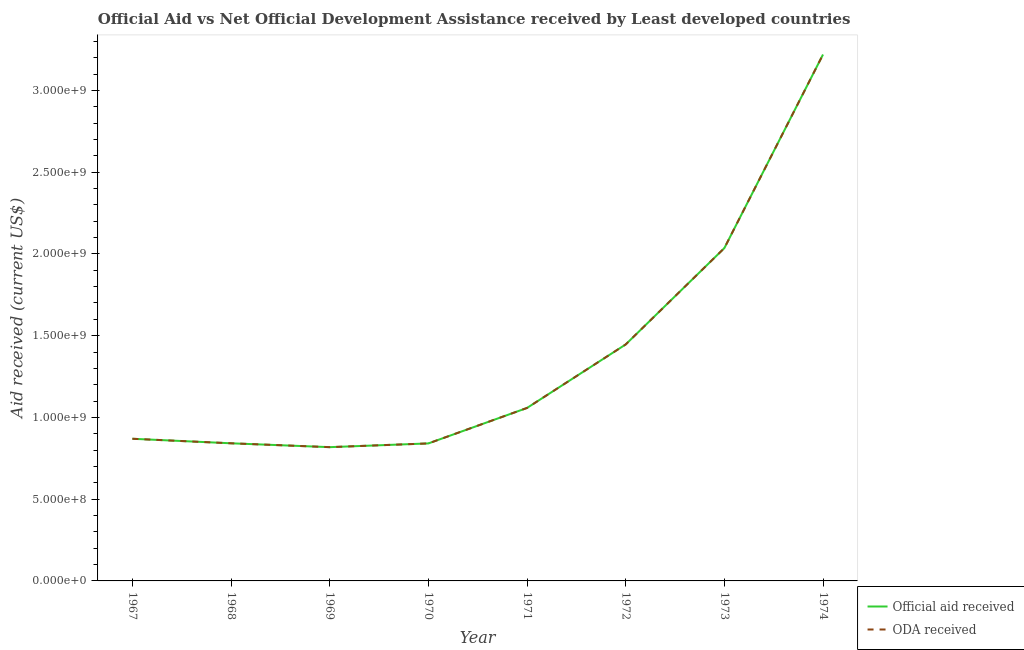What is the official aid received in 1971?
Offer a very short reply. 1.06e+09. Across all years, what is the maximum official aid received?
Give a very brief answer. 3.22e+09. Across all years, what is the minimum official aid received?
Make the answer very short. 8.18e+08. In which year was the oda received maximum?
Your answer should be compact. 1974. In which year was the oda received minimum?
Provide a short and direct response. 1969. What is the total official aid received in the graph?
Your answer should be very brief. 1.11e+1. What is the difference between the official aid received in 1968 and that in 1970?
Provide a short and direct response. 7.80e+05. What is the difference between the oda received in 1969 and the official aid received in 1973?
Ensure brevity in your answer.  -1.22e+09. What is the average oda received per year?
Offer a very short reply. 1.39e+09. In the year 1973, what is the difference between the oda received and official aid received?
Make the answer very short. 0. What is the ratio of the official aid received in 1968 to that in 1970?
Provide a short and direct response. 1. Is the official aid received in 1967 less than that in 1973?
Your answer should be very brief. Yes. Is the difference between the official aid received in 1967 and 1974 greater than the difference between the oda received in 1967 and 1974?
Ensure brevity in your answer.  No. What is the difference between the highest and the second highest official aid received?
Your answer should be very brief. 1.18e+09. What is the difference between the highest and the lowest oda received?
Your answer should be very brief. 2.40e+09. Is the official aid received strictly less than the oda received over the years?
Offer a very short reply. No. How many lines are there?
Ensure brevity in your answer.  2. How many years are there in the graph?
Your response must be concise. 8. Are the values on the major ticks of Y-axis written in scientific E-notation?
Keep it short and to the point. Yes. Where does the legend appear in the graph?
Provide a short and direct response. Bottom right. How many legend labels are there?
Keep it short and to the point. 2. How are the legend labels stacked?
Offer a terse response. Vertical. What is the title of the graph?
Make the answer very short. Official Aid vs Net Official Development Assistance received by Least developed countries . What is the label or title of the Y-axis?
Provide a succinct answer. Aid received (current US$). What is the Aid received (current US$) in Official aid received in 1967?
Keep it short and to the point. 8.69e+08. What is the Aid received (current US$) of ODA received in 1967?
Your answer should be very brief. 8.69e+08. What is the Aid received (current US$) in Official aid received in 1968?
Give a very brief answer. 8.42e+08. What is the Aid received (current US$) in ODA received in 1968?
Keep it short and to the point. 8.42e+08. What is the Aid received (current US$) in Official aid received in 1969?
Your answer should be very brief. 8.18e+08. What is the Aid received (current US$) of ODA received in 1969?
Your response must be concise. 8.18e+08. What is the Aid received (current US$) of Official aid received in 1970?
Offer a very short reply. 8.41e+08. What is the Aid received (current US$) of ODA received in 1970?
Provide a short and direct response. 8.41e+08. What is the Aid received (current US$) in Official aid received in 1971?
Ensure brevity in your answer.  1.06e+09. What is the Aid received (current US$) of ODA received in 1971?
Keep it short and to the point. 1.06e+09. What is the Aid received (current US$) of Official aid received in 1972?
Your answer should be very brief. 1.45e+09. What is the Aid received (current US$) of ODA received in 1972?
Give a very brief answer. 1.45e+09. What is the Aid received (current US$) in Official aid received in 1973?
Provide a short and direct response. 2.04e+09. What is the Aid received (current US$) of ODA received in 1973?
Offer a terse response. 2.04e+09. What is the Aid received (current US$) in Official aid received in 1974?
Give a very brief answer. 3.22e+09. What is the Aid received (current US$) in ODA received in 1974?
Provide a short and direct response. 3.22e+09. Across all years, what is the maximum Aid received (current US$) in Official aid received?
Offer a very short reply. 3.22e+09. Across all years, what is the maximum Aid received (current US$) in ODA received?
Give a very brief answer. 3.22e+09. Across all years, what is the minimum Aid received (current US$) in Official aid received?
Your response must be concise. 8.18e+08. Across all years, what is the minimum Aid received (current US$) in ODA received?
Your answer should be very brief. 8.18e+08. What is the total Aid received (current US$) of Official aid received in the graph?
Offer a terse response. 1.11e+1. What is the total Aid received (current US$) in ODA received in the graph?
Keep it short and to the point. 1.11e+1. What is the difference between the Aid received (current US$) of Official aid received in 1967 and that in 1968?
Keep it short and to the point. 2.77e+07. What is the difference between the Aid received (current US$) of ODA received in 1967 and that in 1968?
Provide a short and direct response. 2.77e+07. What is the difference between the Aid received (current US$) in Official aid received in 1967 and that in 1969?
Ensure brevity in your answer.  5.13e+07. What is the difference between the Aid received (current US$) in ODA received in 1967 and that in 1969?
Make the answer very short. 5.13e+07. What is the difference between the Aid received (current US$) of Official aid received in 1967 and that in 1970?
Your response must be concise. 2.85e+07. What is the difference between the Aid received (current US$) of ODA received in 1967 and that in 1970?
Your answer should be very brief. 2.85e+07. What is the difference between the Aid received (current US$) in Official aid received in 1967 and that in 1971?
Offer a very short reply. -1.88e+08. What is the difference between the Aid received (current US$) of ODA received in 1967 and that in 1971?
Give a very brief answer. -1.88e+08. What is the difference between the Aid received (current US$) of Official aid received in 1967 and that in 1972?
Your answer should be very brief. -5.77e+08. What is the difference between the Aid received (current US$) of ODA received in 1967 and that in 1972?
Your response must be concise. -5.77e+08. What is the difference between the Aid received (current US$) of Official aid received in 1967 and that in 1973?
Your answer should be compact. -1.17e+09. What is the difference between the Aid received (current US$) of ODA received in 1967 and that in 1973?
Provide a short and direct response. -1.17e+09. What is the difference between the Aid received (current US$) in Official aid received in 1967 and that in 1974?
Your answer should be compact. -2.35e+09. What is the difference between the Aid received (current US$) in ODA received in 1967 and that in 1974?
Provide a succinct answer. -2.35e+09. What is the difference between the Aid received (current US$) of Official aid received in 1968 and that in 1969?
Provide a short and direct response. 2.36e+07. What is the difference between the Aid received (current US$) of ODA received in 1968 and that in 1969?
Provide a short and direct response. 2.36e+07. What is the difference between the Aid received (current US$) in Official aid received in 1968 and that in 1970?
Your answer should be compact. 7.80e+05. What is the difference between the Aid received (current US$) in ODA received in 1968 and that in 1970?
Provide a short and direct response. 7.80e+05. What is the difference between the Aid received (current US$) of Official aid received in 1968 and that in 1971?
Your answer should be compact. -2.16e+08. What is the difference between the Aid received (current US$) in ODA received in 1968 and that in 1971?
Make the answer very short. -2.16e+08. What is the difference between the Aid received (current US$) in Official aid received in 1968 and that in 1972?
Provide a succinct answer. -6.05e+08. What is the difference between the Aid received (current US$) in ODA received in 1968 and that in 1972?
Provide a short and direct response. -6.05e+08. What is the difference between the Aid received (current US$) of Official aid received in 1968 and that in 1973?
Your response must be concise. -1.19e+09. What is the difference between the Aid received (current US$) of ODA received in 1968 and that in 1973?
Your response must be concise. -1.19e+09. What is the difference between the Aid received (current US$) in Official aid received in 1968 and that in 1974?
Your response must be concise. -2.38e+09. What is the difference between the Aid received (current US$) of ODA received in 1968 and that in 1974?
Your response must be concise. -2.38e+09. What is the difference between the Aid received (current US$) of Official aid received in 1969 and that in 1970?
Provide a succinct answer. -2.28e+07. What is the difference between the Aid received (current US$) in ODA received in 1969 and that in 1970?
Your answer should be very brief. -2.28e+07. What is the difference between the Aid received (current US$) in Official aid received in 1969 and that in 1971?
Provide a succinct answer. -2.40e+08. What is the difference between the Aid received (current US$) of ODA received in 1969 and that in 1971?
Your answer should be compact. -2.40e+08. What is the difference between the Aid received (current US$) of Official aid received in 1969 and that in 1972?
Offer a very short reply. -6.28e+08. What is the difference between the Aid received (current US$) in ODA received in 1969 and that in 1972?
Your response must be concise. -6.28e+08. What is the difference between the Aid received (current US$) in Official aid received in 1969 and that in 1973?
Offer a terse response. -1.22e+09. What is the difference between the Aid received (current US$) of ODA received in 1969 and that in 1973?
Ensure brevity in your answer.  -1.22e+09. What is the difference between the Aid received (current US$) of Official aid received in 1969 and that in 1974?
Give a very brief answer. -2.40e+09. What is the difference between the Aid received (current US$) in ODA received in 1969 and that in 1974?
Keep it short and to the point. -2.40e+09. What is the difference between the Aid received (current US$) in Official aid received in 1970 and that in 1971?
Offer a terse response. -2.17e+08. What is the difference between the Aid received (current US$) in ODA received in 1970 and that in 1971?
Give a very brief answer. -2.17e+08. What is the difference between the Aid received (current US$) in Official aid received in 1970 and that in 1972?
Your answer should be compact. -6.05e+08. What is the difference between the Aid received (current US$) in ODA received in 1970 and that in 1972?
Your response must be concise. -6.05e+08. What is the difference between the Aid received (current US$) in Official aid received in 1970 and that in 1973?
Keep it short and to the point. -1.19e+09. What is the difference between the Aid received (current US$) of ODA received in 1970 and that in 1973?
Provide a short and direct response. -1.19e+09. What is the difference between the Aid received (current US$) of Official aid received in 1970 and that in 1974?
Make the answer very short. -2.38e+09. What is the difference between the Aid received (current US$) of ODA received in 1970 and that in 1974?
Your answer should be very brief. -2.38e+09. What is the difference between the Aid received (current US$) in Official aid received in 1971 and that in 1972?
Your answer should be compact. -3.88e+08. What is the difference between the Aid received (current US$) of ODA received in 1971 and that in 1972?
Make the answer very short. -3.88e+08. What is the difference between the Aid received (current US$) in Official aid received in 1971 and that in 1973?
Offer a terse response. -9.78e+08. What is the difference between the Aid received (current US$) of ODA received in 1971 and that in 1973?
Offer a terse response. -9.78e+08. What is the difference between the Aid received (current US$) in Official aid received in 1971 and that in 1974?
Offer a very short reply. -2.16e+09. What is the difference between the Aid received (current US$) of ODA received in 1971 and that in 1974?
Your answer should be compact. -2.16e+09. What is the difference between the Aid received (current US$) in Official aid received in 1972 and that in 1973?
Ensure brevity in your answer.  -5.89e+08. What is the difference between the Aid received (current US$) of ODA received in 1972 and that in 1973?
Your answer should be very brief. -5.89e+08. What is the difference between the Aid received (current US$) in Official aid received in 1972 and that in 1974?
Provide a succinct answer. -1.77e+09. What is the difference between the Aid received (current US$) of ODA received in 1972 and that in 1974?
Your response must be concise. -1.77e+09. What is the difference between the Aid received (current US$) of Official aid received in 1973 and that in 1974?
Offer a terse response. -1.18e+09. What is the difference between the Aid received (current US$) of ODA received in 1973 and that in 1974?
Give a very brief answer. -1.18e+09. What is the difference between the Aid received (current US$) in Official aid received in 1967 and the Aid received (current US$) in ODA received in 1968?
Your response must be concise. 2.77e+07. What is the difference between the Aid received (current US$) in Official aid received in 1967 and the Aid received (current US$) in ODA received in 1969?
Ensure brevity in your answer.  5.13e+07. What is the difference between the Aid received (current US$) in Official aid received in 1967 and the Aid received (current US$) in ODA received in 1970?
Provide a succinct answer. 2.85e+07. What is the difference between the Aid received (current US$) of Official aid received in 1967 and the Aid received (current US$) of ODA received in 1971?
Keep it short and to the point. -1.88e+08. What is the difference between the Aid received (current US$) of Official aid received in 1967 and the Aid received (current US$) of ODA received in 1972?
Provide a short and direct response. -5.77e+08. What is the difference between the Aid received (current US$) in Official aid received in 1967 and the Aid received (current US$) in ODA received in 1973?
Your answer should be very brief. -1.17e+09. What is the difference between the Aid received (current US$) of Official aid received in 1967 and the Aid received (current US$) of ODA received in 1974?
Your response must be concise. -2.35e+09. What is the difference between the Aid received (current US$) in Official aid received in 1968 and the Aid received (current US$) in ODA received in 1969?
Your response must be concise. 2.36e+07. What is the difference between the Aid received (current US$) in Official aid received in 1968 and the Aid received (current US$) in ODA received in 1970?
Provide a succinct answer. 7.80e+05. What is the difference between the Aid received (current US$) in Official aid received in 1968 and the Aid received (current US$) in ODA received in 1971?
Give a very brief answer. -2.16e+08. What is the difference between the Aid received (current US$) in Official aid received in 1968 and the Aid received (current US$) in ODA received in 1972?
Your answer should be very brief. -6.05e+08. What is the difference between the Aid received (current US$) of Official aid received in 1968 and the Aid received (current US$) of ODA received in 1973?
Give a very brief answer. -1.19e+09. What is the difference between the Aid received (current US$) in Official aid received in 1968 and the Aid received (current US$) in ODA received in 1974?
Offer a terse response. -2.38e+09. What is the difference between the Aid received (current US$) of Official aid received in 1969 and the Aid received (current US$) of ODA received in 1970?
Your response must be concise. -2.28e+07. What is the difference between the Aid received (current US$) of Official aid received in 1969 and the Aid received (current US$) of ODA received in 1971?
Keep it short and to the point. -2.40e+08. What is the difference between the Aid received (current US$) in Official aid received in 1969 and the Aid received (current US$) in ODA received in 1972?
Keep it short and to the point. -6.28e+08. What is the difference between the Aid received (current US$) of Official aid received in 1969 and the Aid received (current US$) of ODA received in 1973?
Your answer should be very brief. -1.22e+09. What is the difference between the Aid received (current US$) in Official aid received in 1969 and the Aid received (current US$) in ODA received in 1974?
Provide a succinct answer. -2.40e+09. What is the difference between the Aid received (current US$) of Official aid received in 1970 and the Aid received (current US$) of ODA received in 1971?
Your answer should be very brief. -2.17e+08. What is the difference between the Aid received (current US$) in Official aid received in 1970 and the Aid received (current US$) in ODA received in 1972?
Your answer should be very brief. -6.05e+08. What is the difference between the Aid received (current US$) in Official aid received in 1970 and the Aid received (current US$) in ODA received in 1973?
Offer a very short reply. -1.19e+09. What is the difference between the Aid received (current US$) in Official aid received in 1970 and the Aid received (current US$) in ODA received in 1974?
Offer a terse response. -2.38e+09. What is the difference between the Aid received (current US$) of Official aid received in 1971 and the Aid received (current US$) of ODA received in 1972?
Ensure brevity in your answer.  -3.88e+08. What is the difference between the Aid received (current US$) of Official aid received in 1971 and the Aid received (current US$) of ODA received in 1973?
Keep it short and to the point. -9.78e+08. What is the difference between the Aid received (current US$) in Official aid received in 1971 and the Aid received (current US$) in ODA received in 1974?
Make the answer very short. -2.16e+09. What is the difference between the Aid received (current US$) of Official aid received in 1972 and the Aid received (current US$) of ODA received in 1973?
Make the answer very short. -5.89e+08. What is the difference between the Aid received (current US$) in Official aid received in 1972 and the Aid received (current US$) in ODA received in 1974?
Keep it short and to the point. -1.77e+09. What is the difference between the Aid received (current US$) in Official aid received in 1973 and the Aid received (current US$) in ODA received in 1974?
Give a very brief answer. -1.18e+09. What is the average Aid received (current US$) of Official aid received per year?
Offer a very short reply. 1.39e+09. What is the average Aid received (current US$) in ODA received per year?
Your answer should be very brief. 1.39e+09. In the year 1967, what is the difference between the Aid received (current US$) of Official aid received and Aid received (current US$) of ODA received?
Keep it short and to the point. 0. In the year 1968, what is the difference between the Aid received (current US$) of Official aid received and Aid received (current US$) of ODA received?
Provide a short and direct response. 0. In the year 1969, what is the difference between the Aid received (current US$) in Official aid received and Aid received (current US$) in ODA received?
Ensure brevity in your answer.  0. In the year 1971, what is the difference between the Aid received (current US$) of Official aid received and Aid received (current US$) of ODA received?
Your response must be concise. 0. In the year 1972, what is the difference between the Aid received (current US$) in Official aid received and Aid received (current US$) in ODA received?
Offer a very short reply. 0. In the year 1973, what is the difference between the Aid received (current US$) of Official aid received and Aid received (current US$) of ODA received?
Make the answer very short. 0. In the year 1974, what is the difference between the Aid received (current US$) in Official aid received and Aid received (current US$) in ODA received?
Offer a very short reply. 0. What is the ratio of the Aid received (current US$) of Official aid received in 1967 to that in 1968?
Provide a short and direct response. 1.03. What is the ratio of the Aid received (current US$) of ODA received in 1967 to that in 1968?
Provide a succinct answer. 1.03. What is the ratio of the Aid received (current US$) of Official aid received in 1967 to that in 1969?
Provide a short and direct response. 1.06. What is the ratio of the Aid received (current US$) in ODA received in 1967 to that in 1969?
Make the answer very short. 1.06. What is the ratio of the Aid received (current US$) in Official aid received in 1967 to that in 1970?
Provide a short and direct response. 1.03. What is the ratio of the Aid received (current US$) of ODA received in 1967 to that in 1970?
Make the answer very short. 1.03. What is the ratio of the Aid received (current US$) of Official aid received in 1967 to that in 1971?
Your answer should be very brief. 0.82. What is the ratio of the Aid received (current US$) in ODA received in 1967 to that in 1971?
Keep it short and to the point. 0.82. What is the ratio of the Aid received (current US$) in Official aid received in 1967 to that in 1972?
Provide a short and direct response. 0.6. What is the ratio of the Aid received (current US$) in ODA received in 1967 to that in 1972?
Provide a short and direct response. 0.6. What is the ratio of the Aid received (current US$) of Official aid received in 1967 to that in 1973?
Offer a very short reply. 0.43. What is the ratio of the Aid received (current US$) of ODA received in 1967 to that in 1973?
Provide a succinct answer. 0.43. What is the ratio of the Aid received (current US$) in Official aid received in 1967 to that in 1974?
Offer a terse response. 0.27. What is the ratio of the Aid received (current US$) in ODA received in 1967 to that in 1974?
Keep it short and to the point. 0.27. What is the ratio of the Aid received (current US$) of Official aid received in 1968 to that in 1969?
Make the answer very short. 1.03. What is the ratio of the Aid received (current US$) in ODA received in 1968 to that in 1969?
Your answer should be compact. 1.03. What is the ratio of the Aid received (current US$) of Official aid received in 1968 to that in 1970?
Your answer should be very brief. 1. What is the ratio of the Aid received (current US$) in ODA received in 1968 to that in 1970?
Your response must be concise. 1. What is the ratio of the Aid received (current US$) in Official aid received in 1968 to that in 1971?
Offer a terse response. 0.8. What is the ratio of the Aid received (current US$) in ODA received in 1968 to that in 1971?
Make the answer very short. 0.8. What is the ratio of the Aid received (current US$) of Official aid received in 1968 to that in 1972?
Give a very brief answer. 0.58. What is the ratio of the Aid received (current US$) in ODA received in 1968 to that in 1972?
Offer a terse response. 0.58. What is the ratio of the Aid received (current US$) of Official aid received in 1968 to that in 1973?
Your answer should be very brief. 0.41. What is the ratio of the Aid received (current US$) of ODA received in 1968 to that in 1973?
Your answer should be very brief. 0.41. What is the ratio of the Aid received (current US$) in Official aid received in 1968 to that in 1974?
Provide a succinct answer. 0.26. What is the ratio of the Aid received (current US$) in ODA received in 1968 to that in 1974?
Your response must be concise. 0.26. What is the ratio of the Aid received (current US$) of Official aid received in 1969 to that in 1970?
Provide a short and direct response. 0.97. What is the ratio of the Aid received (current US$) of ODA received in 1969 to that in 1970?
Offer a terse response. 0.97. What is the ratio of the Aid received (current US$) in Official aid received in 1969 to that in 1971?
Keep it short and to the point. 0.77. What is the ratio of the Aid received (current US$) in ODA received in 1969 to that in 1971?
Give a very brief answer. 0.77. What is the ratio of the Aid received (current US$) in Official aid received in 1969 to that in 1972?
Provide a succinct answer. 0.57. What is the ratio of the Aid received (current US$) of ODA received in 1969 to that in 1972?
Provide a succinct answer. 0.57. What is the ratio of the Aid received (current US$) in Official aid received in 1969 to that in 1973?
Make the answer very short. 0.4. What is the ratio of the Aid received (current US$) in ODA received in 1969 to that in 1973?
Your answer should be compact. 0.4. What is the ratio of the Aid received (current US$) in Official aid received in 1969 to that in 1974?
Offer a very short reply. 0.25. What is the ratio of the Aid received (current US$) of ODA received in 1969 to that in 1974?
Provide a succinct answer. 0.25. What is the ratio of the Aid received (current US$) of Official aid received in 1970 to that in 1971?
Offer a terse response. 0.79. What is the ratio of the Aid received (current US$) of ODA received in 1970 to that in 1971?
Your answer should be very brief. 0.79. What is the ratio of the Aid received (current US$) of Official aid received in 1970 to that in 1972?
Make the answer very short. 0.58. What is the ratio of the Aid received (current US$) in ODA received in 1970 to that in 1972?
Ensure brevity in your answer.  0.58. What is the ratio of the Aid received (current US$) of Official aid received in 1970 to that in 1973?
Make the answer very short. 0.41. What is the ratio of the Aid received (current US$) of ODA received in 1970 to that in 1973?
Give a very brief answer. 0.41. What is the ratio of the Aid received (current US$) in Official aid received in 1970 to that in 1974?
Offer a terse response. 0.26. What is the ratio of the Aid received (current US$) of ODA received in 1970 to that in 1974?
Provide a short and direct response. 0.26. What is the ratio of the Aid received (current US$) of Official aid received in 1971 to that in 1972?
Your response must be concise. 0.73. What is the ratio of the Aid received (current US$) in ODA received in 1971 to that in 1972?
Provide a succinct answer. 0.73. What is the ratio of the Aid received (current US$) of Official aid received in 1971 to that in 1973?
Offer a very short reply. 0.52. What is the ratio of the Aid received (current US$) of ODA received in 1971 to that in 1973?
Provide a succinct answer. 0.52. What is the ratio of the Aid received (current US$) in Official aid received in 1971 to that in 1974?
Provide a short and direct response. 0.33. What is the ratio of the Aid received (current US$) of ODA received in 1971 to that in 1974?
Make the answer very short. 0.33. What is the ratio of the Aid received (current US$) of Official aid received in 1972 to that in 1973?
Keep it short and to the point. 0.71. What is the ratio of the Aid received (current US$) in ODA received in 1972 to that in 1973?
Make the answer very short. 0.71. What is the ratio of the Aid received (current US$) in Official aid received in 1972 to that in 1974?
Make the answer very short. 0.45. What is the ratio of the Aid received (current US$) of ODA received in 1972 to that in 1974?
Offer a terse response. 0.45. What is the ratio of the Aid received (current US$) of Official aid received in 1973 to that in 1974?
Give a very brief answer. 0.63. What is the ratio of the Aid received (current US$) of ODA received in 1973 to that in 1974?
Offer a very short reply. 0.63. What is the difference between the highest and the second highest Aid received (current US$) in Official aid received?
Give a very brief answer. 1.18e+09. What is the difference between the highest and the second highest Aid received (current US$) of ODA received?
Keep it short and to the point. 1.18e+09. What is the difference between the highest and the lowest Aid received (current US$) in Official aid received?
Give a very brief answer. 2.40e+09. What is the difference between the highest and the lowest Aid received (current US$) in ODA received?
Offer a terse response. 2.40e+09. 